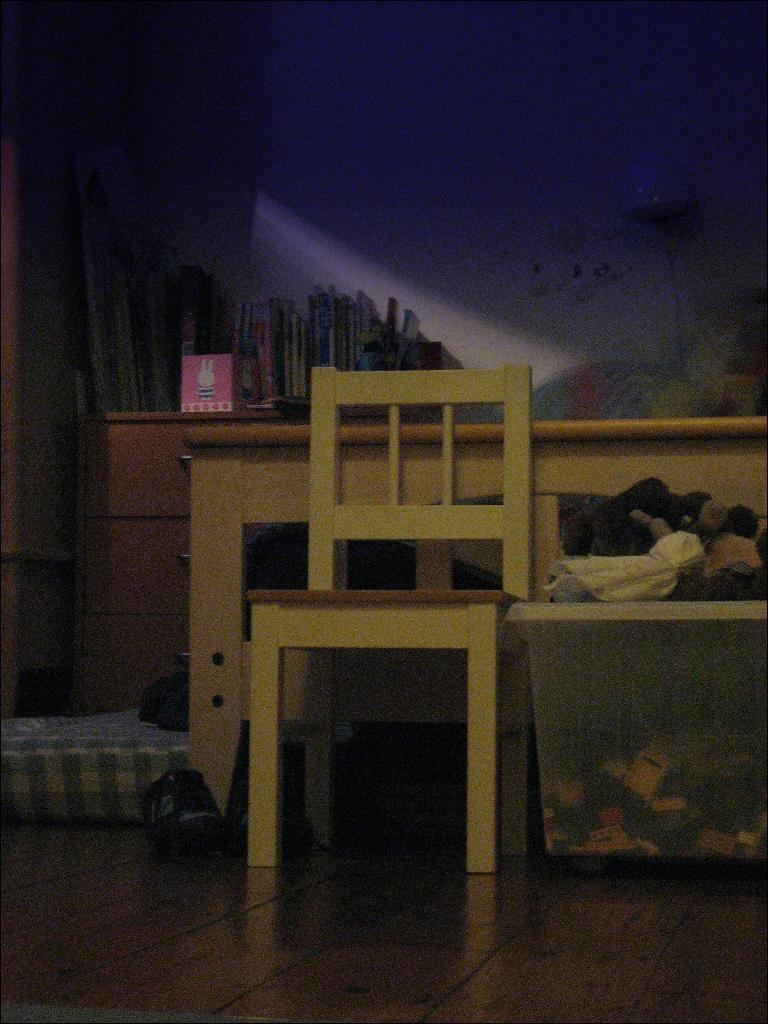Where was the image taken? The image was taken inside a room. What can be seen in the background of the image? There is a table in the background of the image. What piece of furniture is present in the image? There is a chair in the image. What is visible on the wall in the image? There is a wall in the image. What type of items can be seen in the image? There are clothes in a basket in the image. What type of bears can be seen playing with the beef in the image? There are no bears or beef present in the image. What type of trousers are the people wearing in the image? There are no people visible in the image, so it is impossible to determine what type of trousers they might be wearing. 